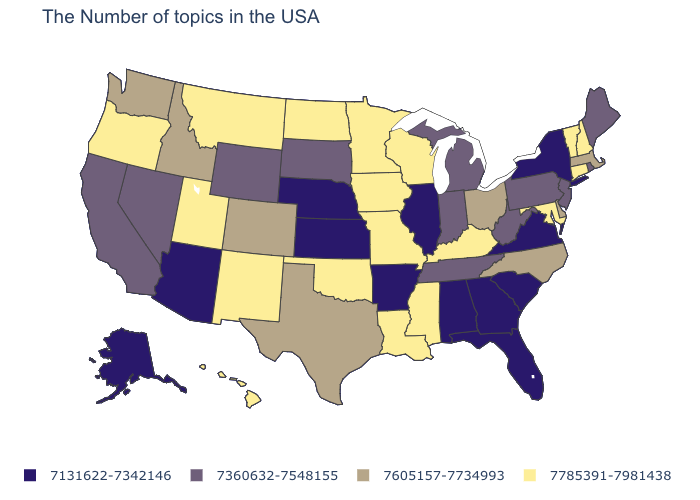Name the states that have a value in the range 7785391-7981438?
Concise answer only. New Hampshire, Vermont, Connecticut, Maryland, Kentucky, Wisconsin, Mississippi, Louisiana, Missouri, Minnesota, Iowa, Oklahoma, North Dakota, New Mexico, Utah, Montana, Oregon, Hawaii. Is the legend a continuous bar?
Short answer required. No. Name the states that have a value in the range 7360632-7548155?
Short answer required. Maine, Rhode Island, New Jersey, Pennsylvania, West Virginia, Michigan, Indiana, Tennessee, South Dakota, Wyoming, Nevada, California. What is the value of West Virginia?
Keep it brief. 7360632-7548155. Does the first symbol in the legend represent the smallest category?
Answer briefly. Yes. What is the value of Colorado?
Short answer required. 7605157-7734993. What is the value of Connecticut?
Short answer required. 7785391-7981438. Which states have the highest value in the USA?
Short answer required. New Hampshire, Vermont, Connecticut, Maryland, Kentucky, Wisconsin, Mississippi, Louisiana, Missouri, Minnesota, Iowa, Oklahoma, North Dakota, New Mexico, Utah, Montana, Oregon, Hawaii. Does Florida have a lower value than Alaska?
Short answer required. No. What is the value of New York?
Write a very short answer. 7131622-7342146. Among the states that border New York , does Pennsylvania have the highest value?
Concise answer only. No. What is the lowest value in the USA?
Short answer required. 7131622-7342146. What is the highest value in the Northeast ?
Answer briefly. 7785391-7981438. How many symbols are there in the legend?
Keep it brief. 4. What is the lowest value in the South?
Short answer required. 7131622-7342146. 